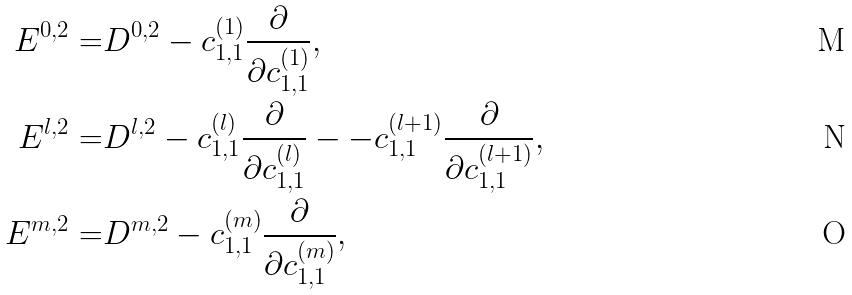Convert formula to latex. <formula><loc_0><loc_0><loc_500><loc_500>E ^ { 0 , 2 } = & D ^ { 0 , 2 } - c ^ { ( 1 ) } _ { 1 , 1 } \frac { \partial } { \partial c ^ { ( 1 ) } _ { 1 , 1 } } , \\ E ^ { l , 2 } = & D ^ { l , 2 } - c ^ { ( l ) } _ { 1 , 1 } \frac { \partial } { \partial c ^ { ( l ) } _ { 1 , 1 } } - - c ^ { ( l + 1 ) } _ { 1 , 1 } \frac { \partial } { \partial c ^ { ( l + 1 ) } _ { 1 , 1 } } , \\ E ^ { m , 2 } = & D ^ { m , 2 } - c ^ { ( m ) } _ { 1 , 1 } \frac { \partial } { \partial c ^ { ( m ) } _ { 1 , 1 } } ,</formula> 